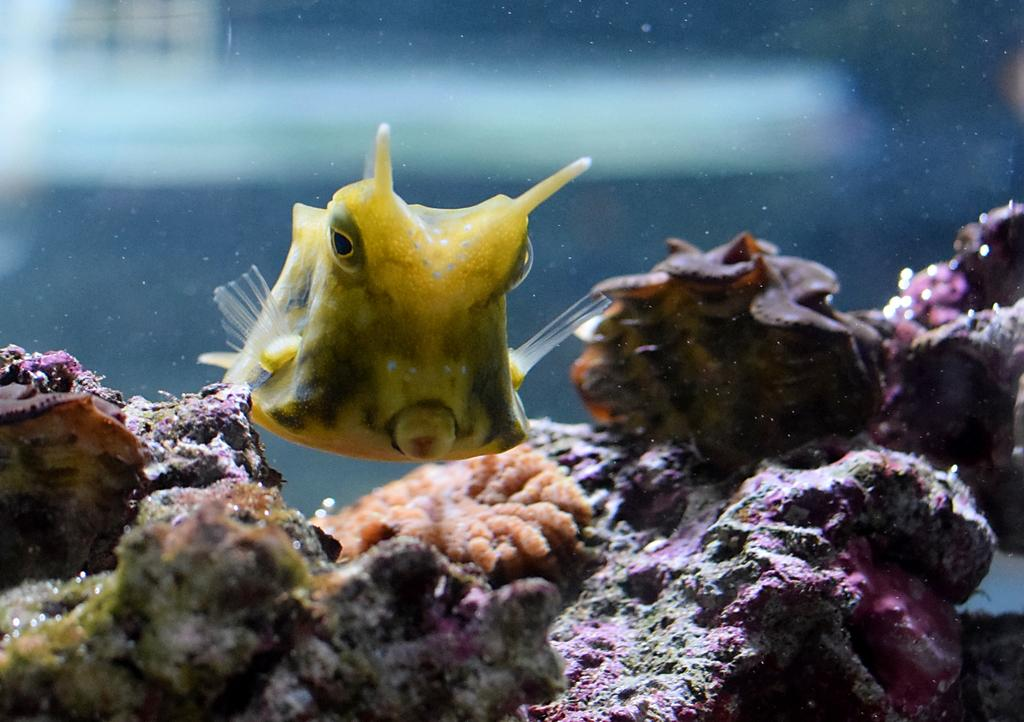What type of animal can be seen in the image? There is a fish in the image. What other objects or features can be seen in the image? There is coral in the image. Can you describe the background of the image? The background of the image is blurry. What rhythm is the fish following in the image? The image does not depict any rhythm or movement of the fish; it is a still image. 